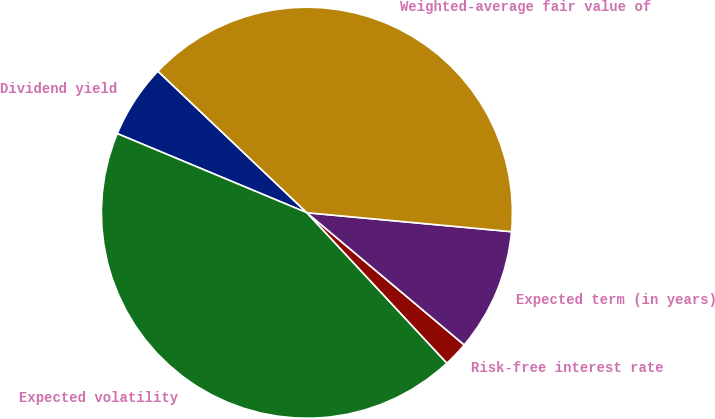Convert chart to OTSL. <chart><loc_0><loc_0><loc_500><loc_500><pie_chart><fcel>Dividend yield<fcel>Expected volatility<fcel>Risk-free interest rate<fcel>Expected term (in years)<fcel>Weighted-average fair value of<nl><fcel>5.8%<fcel>43.22%<fcel>1.95%<fcel>9.65%<fcel>39.38%<nl></chart> 